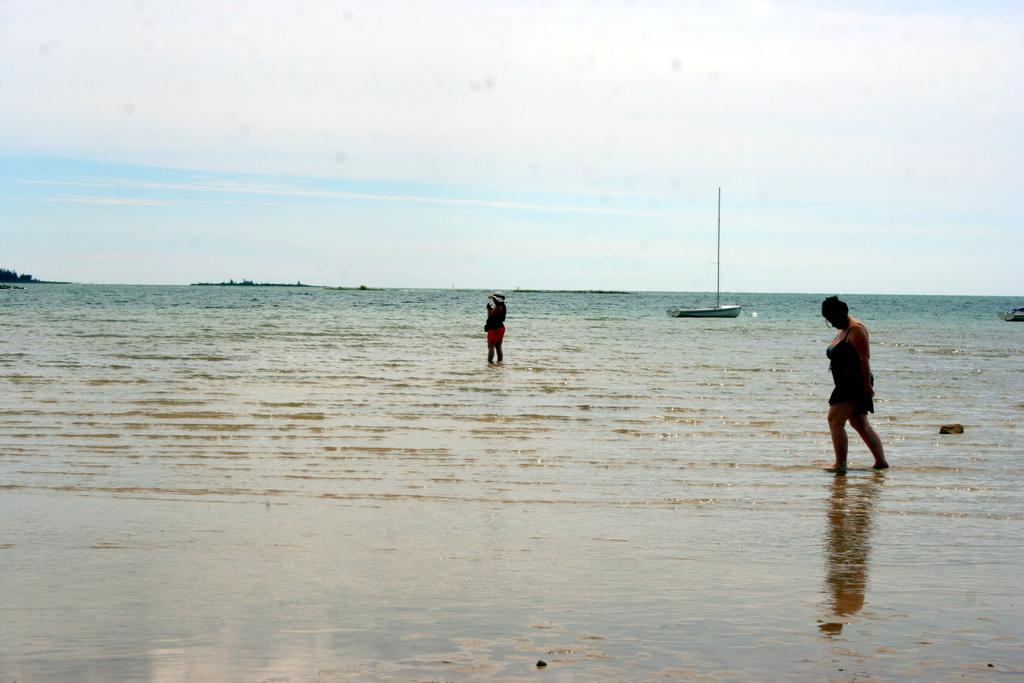What are the two persons in the image doing? The two persons are standing in water. What can be seen in the background of the image? There is a boat with a pole and a mountain visible in the background. What else is visible in the background of the image? The sky is visible in the background. What account number is associated with the boat in the image? There is no account number associated with the boat in the image, as it is not a financial transaction or related to any banking system. 